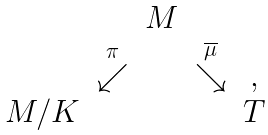Convert formula to latex. <formula><loc_0><loc_0><loc_500><loc_500>\begin{array} { c c c c c } & & M & & \\ & \stackrel { \pi } { \swarrow } & & \stackrel { \overline { \mu } } { \searrow } & , \\ M / K & & & & T \end{array}</formula> 